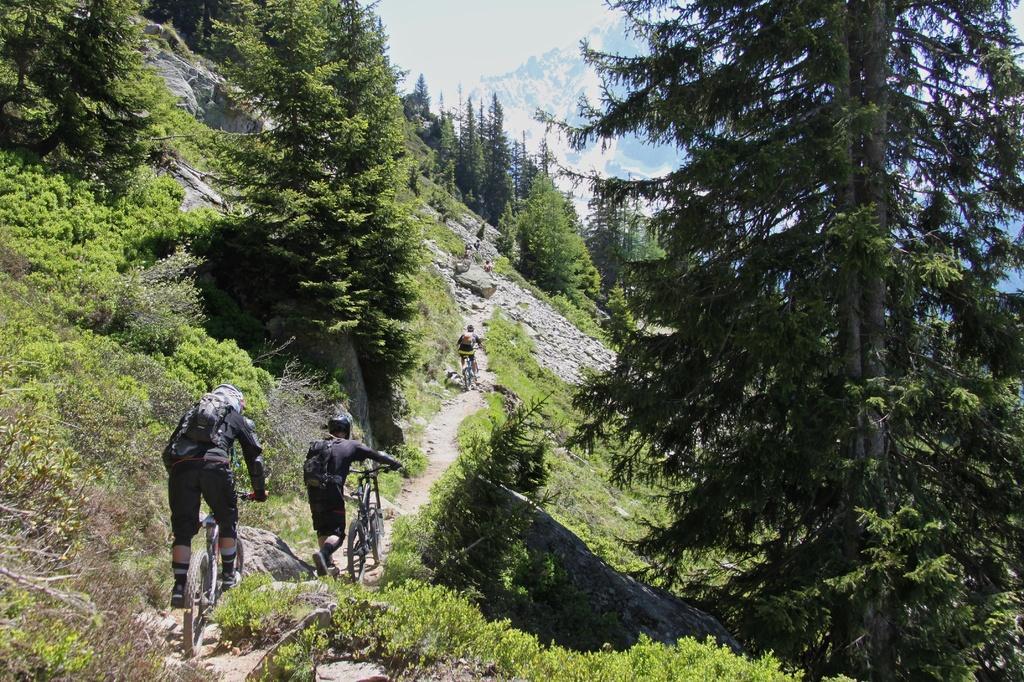Describe this image in one or two sentences. In this image there are some persons who are sitting on cycle and riding, and also there are some trees, plants. And in the background there are mountains and trees, at the bottom there is a walkway. 